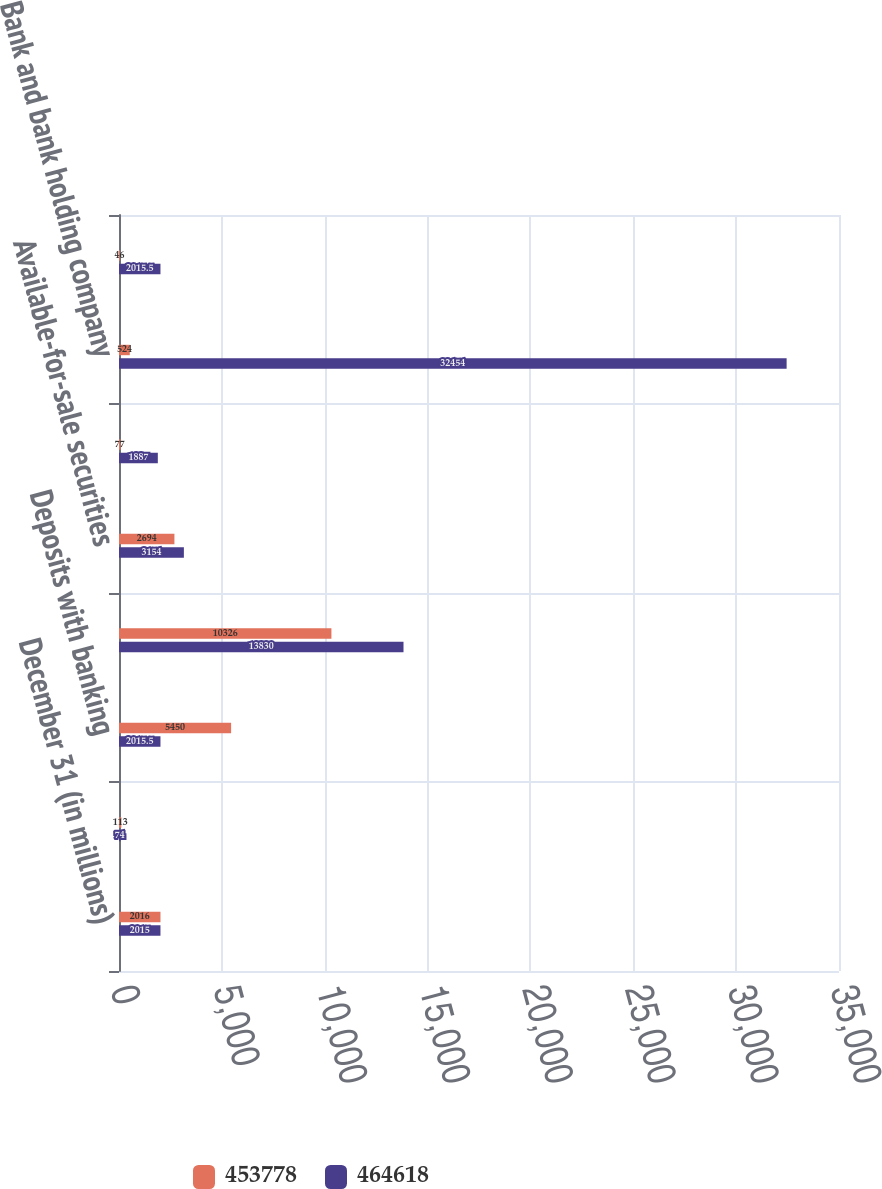Convert chart. <chart><loc_0><loc_0><loc_500><loc_500><stacked_bar_chart><ecel><fcel>December 31 (in millions)<fcel>Cash and due from banks<fcel>Deposits with banking<fcel>Trading assets<fcel>Available-for-sale securities<fcel>Loans<fcel>Bank and bank holding company<fcel>Nonbank<nl><fcel>453778<fcel>2016<fcel>113<fcel>5450<fcel>10326<fcel>2694<fcel>77<fcel>524<fcel>46<nl><fcel>464618<fcel>2015<fcel>74<fcel>2015.5<fcel>13830<fcel>3154<fcel>1887<fcel>32454<fcel>2015.5<nl></chart> 